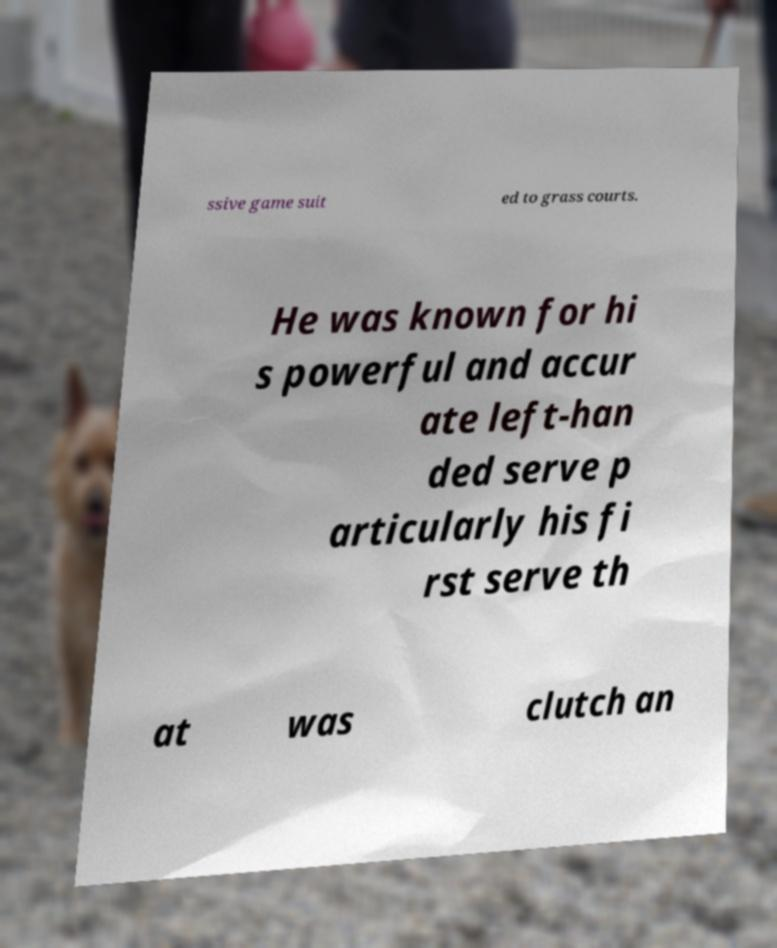I need the written content from this picture converted into text. Can you do that? ssive game suit ed to grass courts. He was known for hi s powerful and accur ate left-han ded serve p articularly his fi rst serve th at was clutch an 